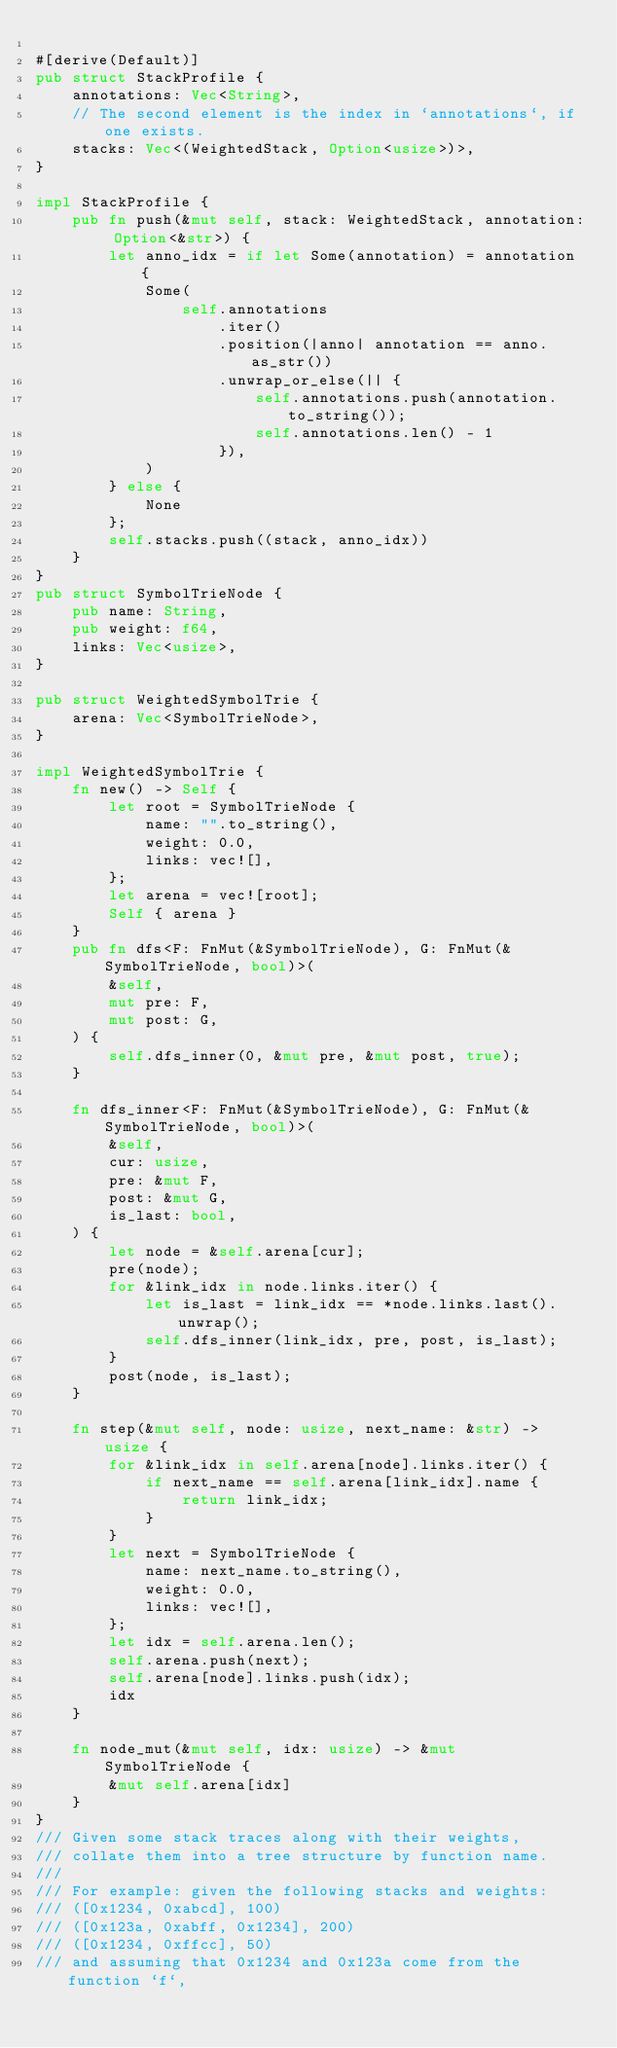Convert code to text. <code><loc_0><loc_0><loc_500><loc_500><_Rust_>
#[derive(Default)]
pub struct StackProfile {
    annotations: Vec<String>,
    // The second element is the index in `annotations`, if one exists.
    stacks: Vec<(WeightedStack, Option<usize>)>,
}

impl StackProfile {
    pub fn push(&mut self, stack: WeightedStack, annotation: Option<&str>) {
        let anno_idx = if let Some(annotation) = annotation {
            Some(
                self.annotations
                    .iter()
                    .position(|anno| annotation == anno.as_str())
                    .unwrap_or_else(|| {
                        self.annotations.push(annotation.to_string());
                        self.annotations.len() - 1
                    }),
            )
        } else {
            None
        };
        self.stacks.push((stack, anno_idx))
    }
}
pub struct SymbolTrieNode {
    pub name: String,
    pub weight: f64,
    links: Vec<usize>,
}

pub struct WeightedSymbolTrie {
    arena: Vec<SymbolTrieNode>,
}

impl WeightedSymbolTrie {
    fn new() -> Self {
        let root = SymbolTrieNode {
            name: "".to_string(),
            weight: 0.0,
            links: vec![],
        };
        let arena = vec![root];
        Self { arena }
    }
    pub fn dfs<F: FnMut(&SymbolTrieNode), G: FnMut(&SymbolTrieNode, bool)>(
        &self,
        mut pre: F,
        mut post: G,
    ) {
        self.dfs_inner(0, &mut pre, &mut post, true);
    }

    fn dfs_inner<F: FnMut(&SymbolTrieNode), G: FnMut(&SymbolTrieNode, bool)>(
        &self,
        cur: usize,
        pre: &mut F,
        post: &mut G,
        is_last: bool,
    ) {
        let node = &self.arena[cur];
        pre(node);
        for &link_idx in node.links.iter() {
            let is_last = link_idx == *node.links.last().unwrap();
            self.dfs_inner(link_idx, pre, post, is_last);
        }
        post(node, is_last);
    }

    fn step(&mut self, node: usize, next_name: &str) -> usize {
        for &link_idx in self.arena[node].links.iter() {
            if next_name == self.arena[link_idx].name {
                return link_idx;
            }
        }
        let next = SymbolTrieNode {
            name: next_name.to_string(),
            weight: 0.0,
            links: vec![],
        };
        let idx = self.arena.len();
        self.arena.push(next);
        self.arena[node].links.push(idx);
        idx
    }

    fn node_mut(&mut self, idx: usize) -> &mut SymbolTrieNode {
        &mut self.arena[idx]
    }
}
/// Given some stack traces along with their weights,
/// collate them into a tree structure by function name.
///
/// For example: given the following stacks and weights:
/// ([0x1234, 0xabcd], 100)
/// ([0x123a, 0xabff, 0x1234], 200)
/// ([0x1234, 0xffcc], 50)
/// and assuming that 0x1234 and 0x123a come from the function `f`,</code> 